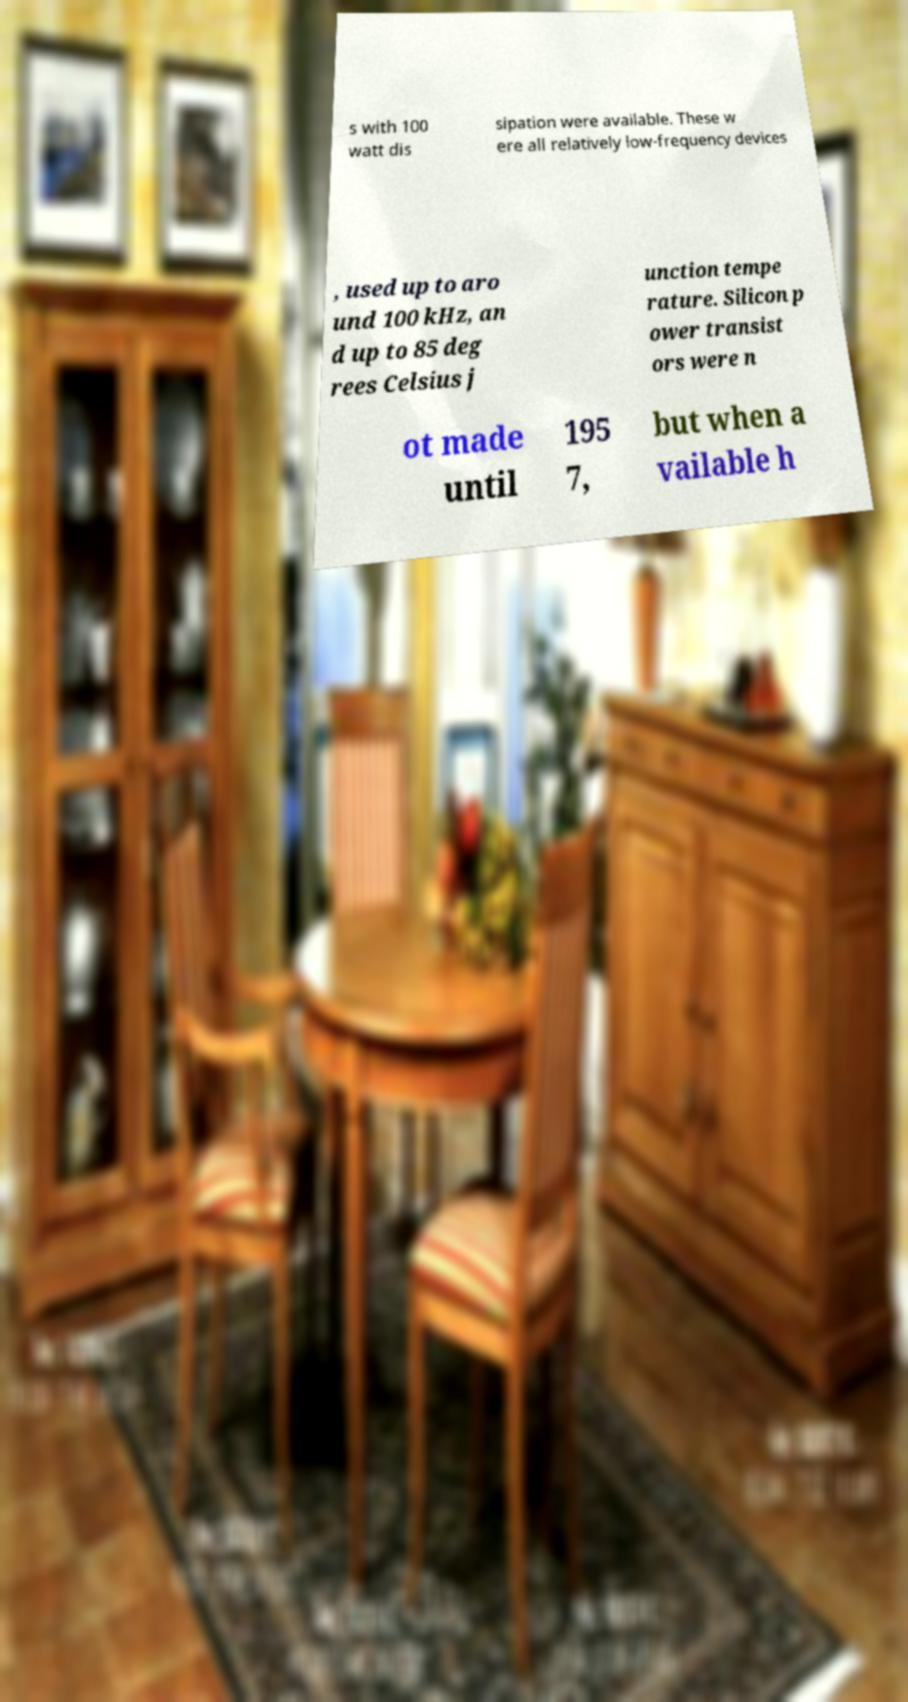Could you extract and type out the text from this image? s with 100 watt dis sipation were available. These w ere all relatively low-frequency devices , used up to aro und 100 kHz, an d up to 85 deg rees Celsius j unction tempe rature. Silicon p ower transist ors were n ot made until 195 7, but when a vailable h 